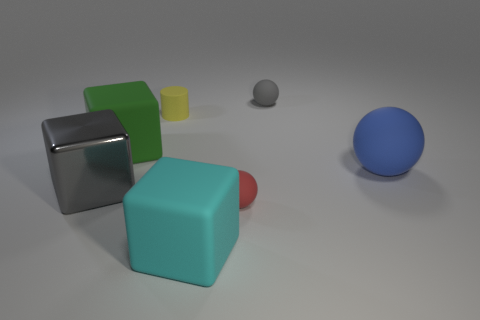Add 2 big green things. How many objects exist? 9 Subtract all cylinders. How many objects are left? 6 Add 5 large red cubes. How many large red cubes exist? 5 Subtract 0 purple blocks. How many objects are left? 7 Subtract all small brown metal objects. Subtract all spheres. How many objects are left? 4 Add 7 green blocks. How many green blocks are left? 8 